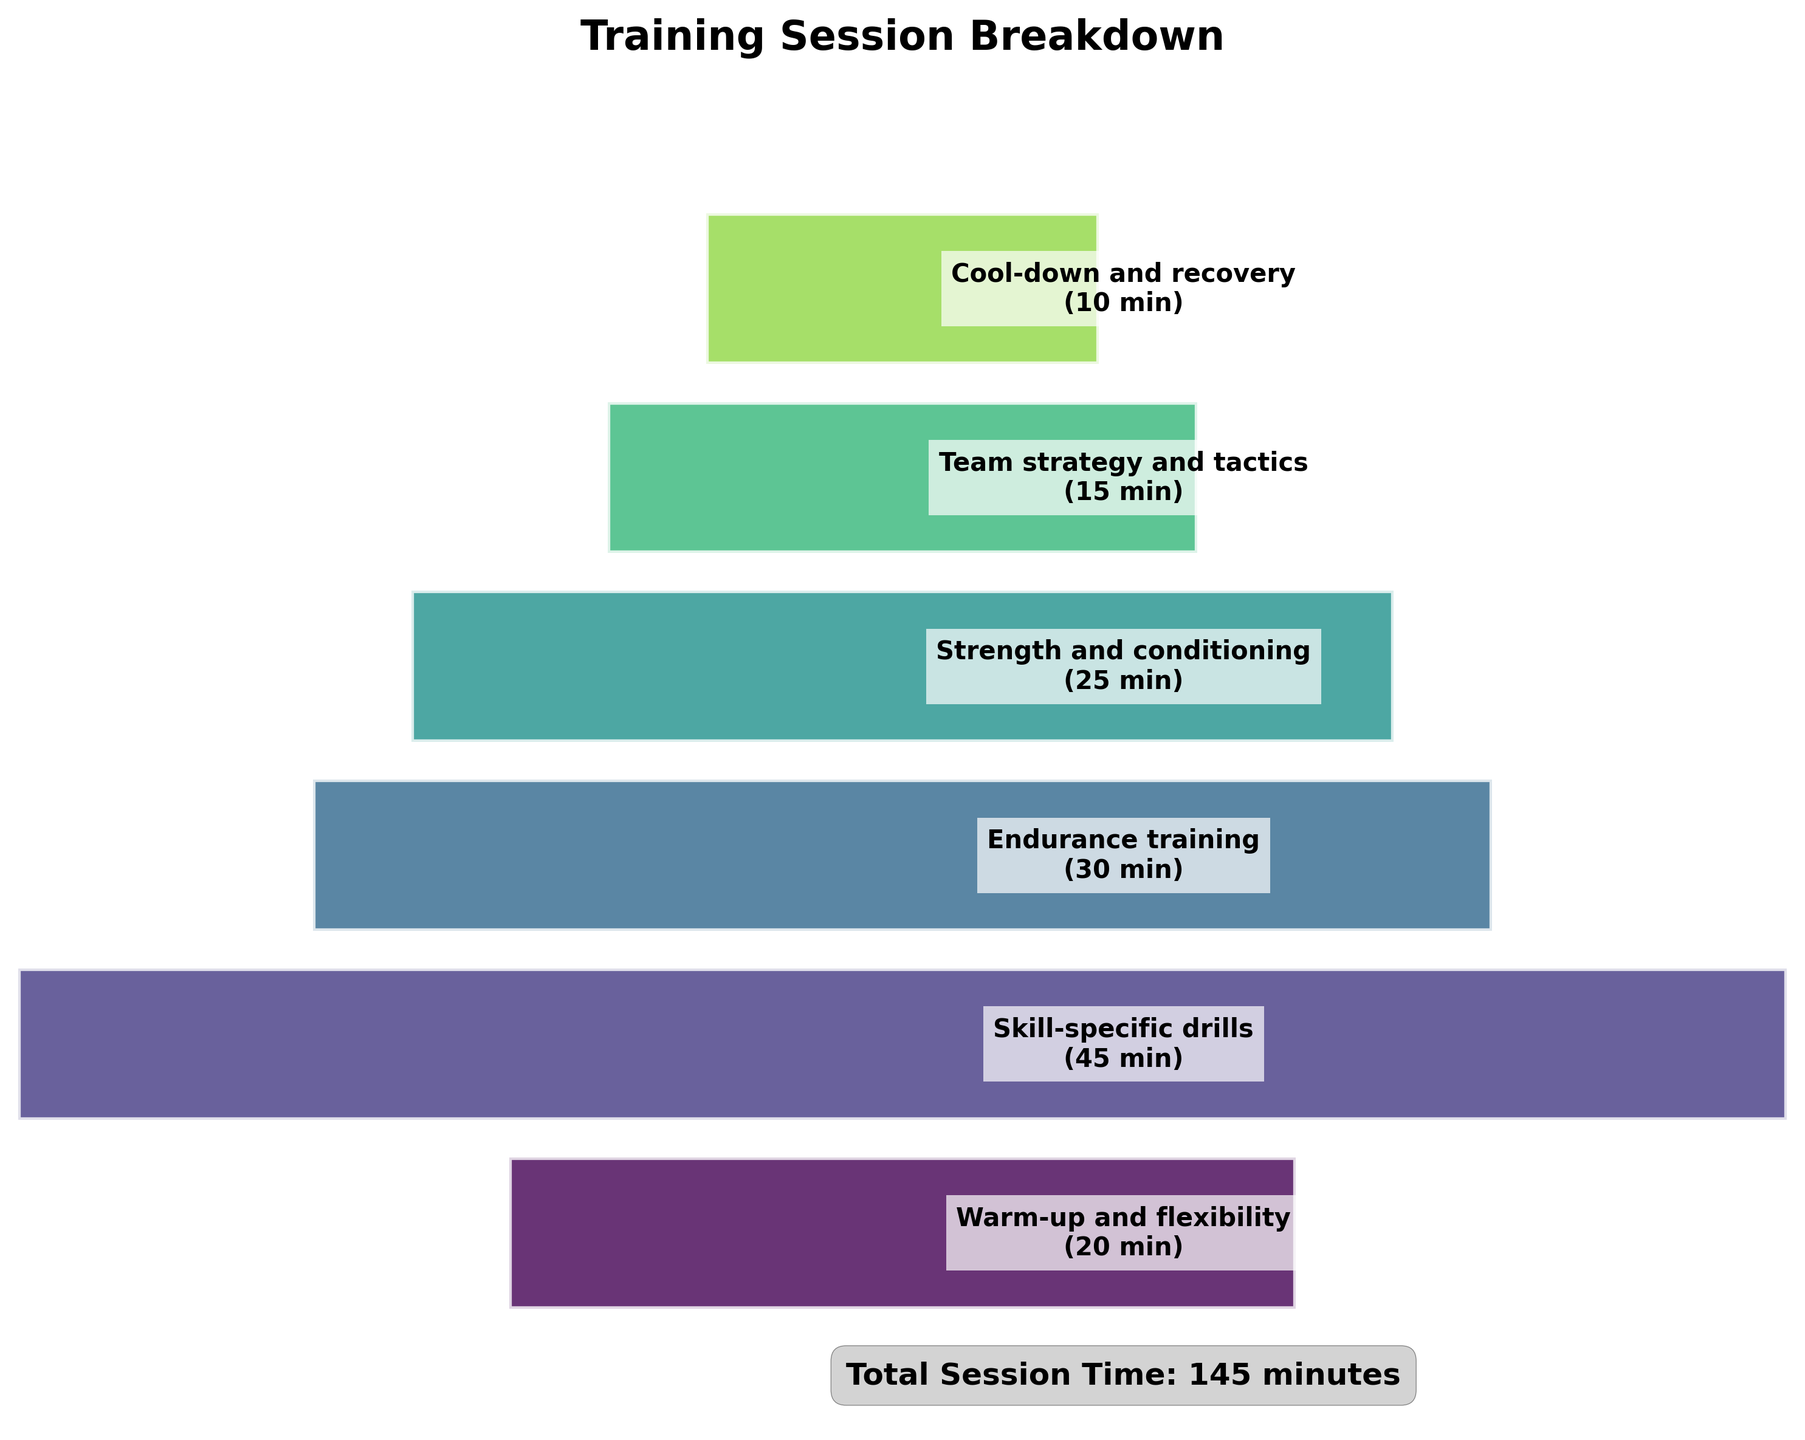What is the title of the plot? The title is located at the top of the plot and provides an overarching description of what the figure represents. It states "Training Session Breakdown".
Answer: Training Session Breakdown How much time is allocated to the Warm-up and flexibility stage? The Warm-up and flexibility stage is listed at the top of the plot, and the time allocation is indicated within the stage's segment. It states "20 min".
Answer: 20 minutes Which training component takes the longest time in the session? Identify the largest segment or the segment with the widest bar on the funnel chart. The Skill-specific drills segment is the largest, and it lists 45 minutes as the time.
Answer: Skill-specific drills What is the total time allocated to Strength and conditioning and Endurance training combined? The time for Strength and conditioning is 25 minutes, and Endurance training is 30 minutes. Adding these times together gives 25 + 30 = 55 minutes.
Answer: 55 minutes Comparatively, how much longer is the Skill-specific drills stage than the Team strategy and tactics stage? The Skill-specific drills stage lasts 45 minutes and the Team strategy and tactics stage lasts 15 minutes. The difference is calculated as 45 - 15 = 30 minutes.
Answer: 30 minutes Which stage of the training has the smallest time allocation? Identify the smallest segment or the one with the narrowest bar on the funnel chart. Cool-down and recovery is the smallest segment, listed with 10 minutes.
Answer: Cool-down and recovery How much more time is allocated to Endurance training compared to Cool-down and recovery? Endurance training is 30 minutes and Cool-down and recovery is 10 minutes. The difference is calculated as 30 - 10 = 20 minutes.
Answer: 20 minutes What is the total duration of the training session? The total time is given at the bottom of the chart. It states "Total Session Time: 145 minutes".
Answer: 145 minutes Which stages form the middle 50% of the training session in terms of time allocation? The total session time is 145 minutes, and the middle 50% would be around 72.5 minutes. Identify the stages that cumulatively add up to approximately this amount, focusing on the central stages in the figure.
Answer: Skill-specific drills and Endurance training If you combine the times for Warm-up and flexibility, Skill-specific drills, and Strength and conditioning, how much time do you get? The times are 20 minutes for Warm-up and flexibility, 45 minutes for Skill-specific drills, and 25 minutes for Strength and conditioning. Adding these gives 20 + 45 + 25 = 90 minutes.
Answer: 90 minutes 